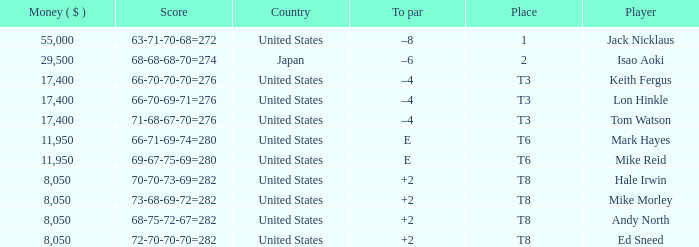What player has money larger than 11,950 and is placed in t8 and has the score of 73-68-69-72=282? None. 